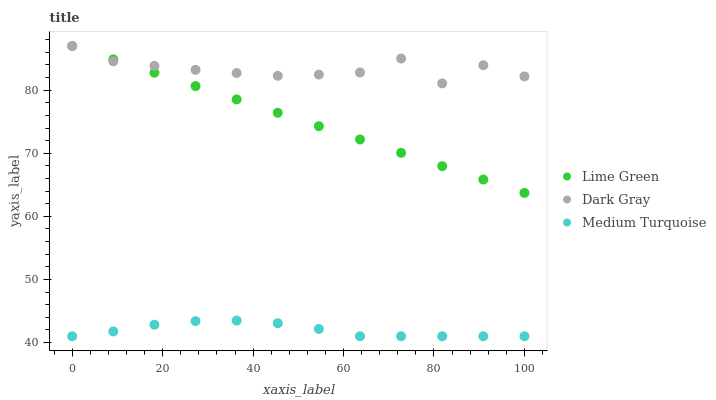Does Medium Turquoise have the minimum area under the curve?
Answer yes or no. Yes. Does Dark Gray have the maximum area under the curve?
Answer yes or no. Yes. Does Lime Green have the minimum area under the curve?
Answer yes or no. No. Does Lime Green have the maximum area under the curve?
Answer yes or no. No. Is Lime Green the smoothest?
Answer yes or no. Yes. Is Dark Gray the roughest?
Answer yes or no. Yes. Is Medium Turquoise the smoothest?
Answer yes or no. No. Is Medium Turquoise the roughest?
Answer yes or no. No. Does Medium Turquoise have the lowest value?
Answer yes or no. Yes. Does Lime Green have the lowest value?
Answer yes or no. No. Does Lime Green have the highest value?
Answer yes or no. Yes. Does Medium Turquoise have the highest value?
Answer yes or no. No. Is Medium Turquoise less than Dark Gray?
Answer yes or no. Yes. Is Lime Green greater than Medium Turquoise?
Answer yes or no. Yes. Does Lime Green intersect Dark Gray?
Answer yes or no. Yes. Is Lime Green less than Dark Gray?
Answer yes or no. No. Is Lime Green greater than Dark Gray?
Answer yes or no. No. Does Medium Turquoise intersect Dark Gray?
Answer yes or no. No. 